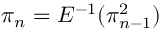Convert formula to latex. <formula><loc_0><loc_0><loc_500><loc_500>\pi _ { n } = E ^ { - 1 } ( \pi _ { n - 1 } ^ { 2 } )</formula> 